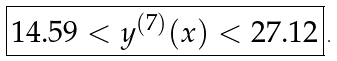<formula> <loc_0><loc_0><loc_500><loc_500>\boxed { 1 4 . 5 9 < y ^ { ( 7 ) } ( x ) < 2 7 . 1 2 } \, .</formula> 